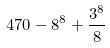Convert formula to latex. <formula><loc_0><loc_0><loc_500><loc_500>4 7 0 - 8 ^ { 8 } + \frac { 3 ^ { 8 } } { 8 }</formula> 